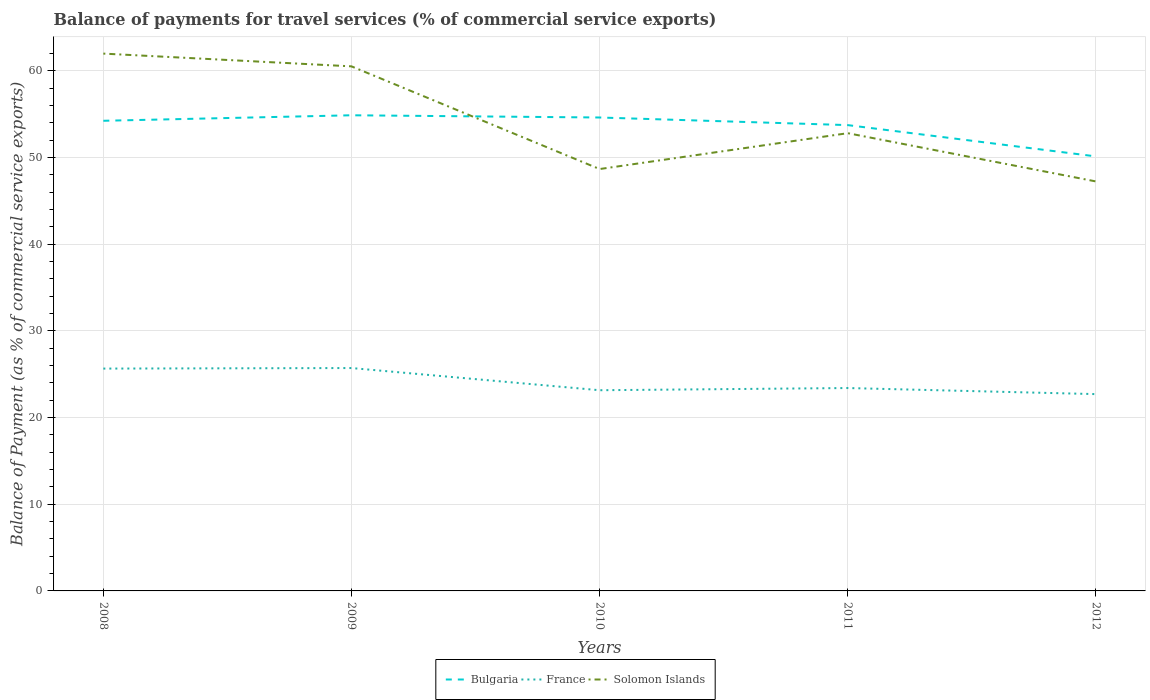How many different coloured lines are there?
Your answer should be very brief. 3. Does the line corresponding to France intersect with the line corresponding to Bulgaria?
Offer a very short reply. No. Across all years, what is the maximum balance of payments for travel services in France?
Offer a very short reply. 22.7. In which year was the balance of payments for travel services in France maximum?
Offer a terse response. 2012. What is the total balance of payments for travel services in Solomon Islands in the graph?
Offer a terse response. 13.28. What is the difference between the highest and the second highest balance of payments for travel services in Bulgaria?
Your answer should be compact. 4.74. What is the difference between the highest and the lowest balance of payments for travel services in Solomon Islands?
Offer a terse response. 2. How many lines are there?
Provide a short and direct response. 3. What is the difference between two consecutive major ticks on the Y-axis?
Offer a very short reply. 10. Are the values on the major ticks of Y-axis written in scientific E-notation?
Make the answer very short. No. Does the graph contain any zero values?
Ensure brevity in your answer.  No. How many legend labels are there?
Ensure brevity in your answer.  3. How are the legend labels stacked?
Give a very brief answer. Horizontal. What is the title of the graph?
Offer a very short reply. Balance of payments for travel services (% of commercial service exports). Does "Portugal" appear as one of the legend labels in the graph?
Make the answer very short. No. What is the label or title of the Y-axis?
Provide a succinct answer. Balance of Payment (as % of commercial service exports). What is the Balance of Payment (as % of commercial service exports) of Bulgaria in 2008?
Ensure brevity in your answer.  54.24. What is the Balance of Payment (as % of commercial service exports) in France in 2008?
Provide a short and direct response. 25.65. What is the Balance of Payment (as % of commercial service exports) in Solomon Islands in 2008?
Ensure brevity in your answer.  61.99. What is the Balance of Payment (as % of commercial service exports) in Bulgaria in 2009?
Give a very brief answer. 54.87. What is the Balance of Payment (as % of commercial service exports) in France in 2009?
Provide a short and direct response. 25.71. What is the Balance of Payment (as % of commercial service exports) in Solomon Islands in 2009?
Your response must be concise. 60.51. What is the Balance of Payment (as % of commercial service exports) in Bulgaria in 2010?
Offer a terse response. 54.61. What is the Balance of Payment (as % of commercial service exports) in France in 2010?
Provide a short and direct response. 23.15. What is the Balance of Payment (as % of commercial service exports) of Solomon Islands in 2010?
Your answer should be compact. 48.67. What is the Balance of Payment (as % of commercial service exports) of Bulgaria in 2011?
Provide a succinct answer. 53.74. What is the Balance of Payment (as % of commercial service exports) of France in 2011?
Provide a short and direct response. 23.4. What is the Balance of Payment (as % of commercial service exports) of Solomon Islands in 2011?
Keep it short and to the point. 52.8. What is the Balance of Payment (as % of commercial service exports) in Bulgaria in 2012?
Ensure brevity in your answer.  50.13. What is the Balance of Payment (as % of commercial service exports) of France in 2012?
Your response must be concise. 22.7. What is the Balance of Payment (as % of commercial service exports) of Solomon Islands in 2012?
Your answer should be very brief. 47.24. Across all years, what is the maximum Balance of Payment (as % of commercial service exports) of Bulgaria?
Your response must be concise. 54.87. Across all years, what is the maximum Balance of Payment (as % of commercial service exports) in France?
Offer a very short reply. 25.71. Across all years, what is the maximum Balance of Payment (as % of commercial service exports) of Solomon Islands?
Provide a succinct answer. 61.99. Across all years, what is the minimum Balance of Payment (as % of commercial service exports) in Bulgaria?
Provide a short and direct response. 50.13. Across all years, what is the minimum Balance of Payment (as % of commercial service exports) in France?
Your answer should be compact. 22.7. Across all years, what is the minimum Balance of Payment (as % of commercial service exports) of Solomon Islands?
Give a very brief answer. 47.24. What is the total Balance of Payment (as % of commercial service exports) in Bulgaria in the graph?
Offer a terse response. 267.59. What is the total Balance of Payment (as % of commercial service exports) of France in the graph?
Your response must be concise. 120.62. What is the total Balance of Payment (as % of commercial service exports) of Solomon Islands in the graph?
Keep it short and to the point. 271.21. What is the difference between the Balance of Payment (as % of commercial service exports) in Bulgaria in 2008 and that in 2009?
Offer a terse response. -0.64. What is the difference between the Balance of Payment (as % of commercial service exports) of France in 2008 and that in 2009?
Give a very brief answer. -0.06. What is the difference between the Balance of Payment (as % of commercial service exports) in Solomon Islands in 2008 and that in 2009?
Keep it short and to the point. 1.47. What is the difference between the Balance of Payment (as % of commercial service exports) of Bulgaria in 2008 and that in 2010?
Make the answer very short. -0.38. What is the difference between the Balance of Payment (as % of commercial service exports) in France in 2008 and that in 2010?
Offer a terse response. 2.5. What is the difference between the Balance of Payment (as % of commercial service exports) in Solomon Islands in 2008 and that in 2010?
Provide a short and direct response. 13.32. What is the difference between the Balance of Payment (as % of commercial service exports) in Bulgaria in 2008 and that in 2011?
Offer a very short reply. 0.5. What is the difference between the Balance of Payment (as % of commercial service exports) of France in 2008 and that in 2011?
Your response must be concise. 2.24. What is the difference between the Balance of Payment (as % of commercial service exports) of Solomon Islands in 2008 and that in 2011?
Provide a succinct answer. 9.18. What is the difference between the Balance of Payment (as % of commercial service exports) in Bulgaria in 2008 and that in 2012?
Your answer should be very brief. 4.11. What is the difference between the Balance of Payment (as % of commercial service exports) of France in 2008 and that in 2012?
Offer a terse response. 2.95. What is the difference between the Balance of Payment (as % of commercial service exports) of Solomon Islands in 2008 and that in 2012?
Make the answer very short. 14.75. What is the difference between the Balance of Payment (as % of commercial service exports) in Bulgaria in 2009 and that in 2010?
Your answer should be very brief. 0.26. What is the difference between the Balance of Payment (as % of commercial service exports) in France in 2009 and that in 2010?
Your answer should be very brief. 2.56. What is the difference between the Balance of Payment (as % of commercial service exports) in Solomon Islands in 2009 and that in 2010?
Your answer should be compact. 11.85. What is the difference between the Balance of Payment (as % of commercial service exports) in Bulgaria in 2009 and that in 2011?
Your response must be concise. 1.13. What is the difference between the Balance of Payment (as % of commercial service exports) in France in 2009 and that in 2011?
Make the answer very short. 2.31. What is the difference between the Balance of Payment (as % of commercial service exports) in Solomon Islands in 2009 and that in 2011?
Offer a very short reply. 7.71. What is the difference between the Balance of Payment (as % of commercial service exports) of Bulgaria in 2009 and that in 2012?
Provide a short and direct response. 4.74. What is the difference between the Balance of Payment (as % of commercial service exports) in France in 2009 and that in 2012?
Make the answer very short. 3.01. What is the difference between the Balance of Payment (as % of commercial service exports) of Solomon Islands in 2009 and that in 2012?
Provide a short and direct response. 13.28. What is the difference between the Balance of Payment (as % of commercial service exports) of Bulgaria in 2010 and that in 2011?
Provide a short and direct response. 0.88. What is the difference between the Balance of Payment (as % of commercial service exports) in France in 2010 and that in 2011?
Ensure brevity in your answer.  -0.25. What is the difference between the Balance of Payment (as % of commercial service exports) in Solomon Islands in 2010 and that in 2011?
Your answer should be compact. -4.14. What is the difference between the Balance of Payment (as % of commercial service exports) in Bulgaria in 2010 and that in 2012?
Offer a very short reply. 4.49. What is the difference between the Balance of Payment (as % of commercial service exports) in France in 2010 and that in 2012?
Your answer should be compact. 0.45. What is the difference between the Balance of Payment (as % of commercial service exports) of Solomon Islands in 2010 and that in 2012?
Offer a very short reply. 1.43. What is the difference between the Balance of Payment (as % of commercial service exports) of Bulgaria in 2011 and that in 2012?
Make the answer very short. 3.61. What is the difference between the Balance of Payment (as % of commercial service exports) in France in 2011 and that in 2012?
Your response must be concise. 0.7. What is the difference between the Balance of Payment (as % of commercial service exports) in Solomon Islands in 2011 and that in 2012?
Provide a succinct answer. 5.57. What is the difference between the Balance of Payment (as % of commercial service exports) in Bulgaria in 2008 and the Balance of Payment (as % of commercial service exports) in France in 2009?
Provide a short and direct response. 28.52. What is the difference between the Balance of Payment (as % of commercial service exports) of Bulgaria in 2008 and the Balance of Payment (as % of commercial service exports) of Solomon Islands in 2009?
Your response must be concise. -6.28. What is the difference between the Balance of Payment (as % of commercial service exports) in France in 2008 and the Balance of Payment (as % of commercial service exports) in Solomon Islands in 2009?
Provide a short and direct response. -34.87. What is the difference between the Balance of Payment (as % of commercial service exports) of Bulgaria in 2008 and the Balance of Payment (as % of commercial service exports) of France in 2010?
Your answer should be compact. 31.08. What is the difference between the Balance of Payment (as % of commercial service exports) in Bulgaria in 2008 and the Balance of Payment (as % of commercial service exports) in Solomon Islands in 2010?
Your answer should be very brief. 5.57. What is the difference between the Balance of Payment (as % of commercial service exports) in France in 2008 and the Balance of Payment (as % of commercial service exports) in Solomon Islands in 2010?
Your answer should be very brief. -23.02. What is the difference between the Balance of Payment (as % of commercial service exports) in Bulgaria in 2008 and the Balance of Payment (as % of commercial service exports) in France in 2011?
Offer a terse response. 30.83. What is the difference between the Balance of Payment (as % of commercial service exports) in Bulgaria in 2008 and the Balance of Payment (as % of commercial service exports) in Solomon Islands in 2011?
Provide a succinct answer. 1.43. What is the difference between the Balance of Payment (as % of commercial service exports) in France in 2008 and the Balance of Payment (as % of commercial service exports) in Solomon Islands in 2011?
Your answer should be compact. -27.16. What is the difference between the Balance of Payment (as % of commercial service exports) of Bulgaria in 2008 and the Balance of Payment (as % of commercial service exports) of France in 2012?
Your answer should be very brief. 31.53. What is the difference between the Balance of Payment (as % of commercial service exports) of Bulgaria in 2008 and the Balance of Payment (as % of commercial service exports) of Solomon Islands in 2012?
Give a very brief answer. 7. What is the difference between the Balance of Payment (as % of commercial service exports) in France in 2008 and the Balance of Payment (as % of commercial service exports) in Solomon Islands in 2012?
Your response must be concise. -21.59. What is the difference between the Balance of Payment (as % of commercial service exports) in Bulgaria in 2009 and the Balance of Payment (as % of commercial service exports) in France in 2010?
Your answer should be very brief. 31.72. What is the difference between the Balance of Payment (as % of commercial service exports) of Bulgaria in 2009 and the Balance of Payment (as % of commercial service exports) of Solomon Islands in 2010?
Offer a very short reply. 6.2. What is the difference between the Balance of Payment (as % of commercial service exports) of France in 2009 and the Balance of Payment (as % of commercial service exports) of Solomon Islands in 2010?
Offer a very short reply. -22.96. What is the difference between the Balance of Payment (as % of commercial service exports) of Bulgaria in 2009 and the Balance of Payment (as % of commercial service exports) of France in 2011?
Offer a terse response. 31.47. What is the difference between the Balance of Payment (as % of commercial service exports) of Bulgaria in 2009 and the Balance of Payment (as % of commercial service exports) of Solomon Islands in 2011?
Provide a short and direct response. 2.07. What is the difference between the Balance of Payment (as % of commercial service exports) in France in 2009 and the Balance of Payment (as % of commercial service exports) in Solomon Islands in 2011?
Keep it short and to the point. -27.09. What is the difference between the Balance of Payment (as % of commercial service exports) in Bulgaria in 2009 and the Balance of Payment (as % of commercial service exports) in France in 2012?
Provide a short and direct response. 32.17. What is the difference between the Balance of Payment (as % of commercial service exports) of Bulgaria in 2009 and the Balance of Payment (as % of commercial service exports) of Solomon Islands in 2012?
Your answer should be very brief. 7.63. What is the difference between the Balance of Payment (as % of commercial service exports) in France in 2009 and the Balance of Payment (as % of commercial service exports) in Solomon Islands in 2012?
Your answer should be very brief. -21.53. What is the difference between the Balance of Payment (as % of commercial service exports) in Bulgaria in 2010 and the Balance of Payment (as % of commercial service exports) in France in 2011?
Provide a succinct answer. 31.21. What is the difference between the Balance of Payment (as % of commercial service exports) of Bulgaria in 2010 and the Balance of Payment (as % of commercial service exports) of Solomon Islands in 2011?
Provide a short and direct response. 1.81. What is the difference between the Balance of Payment (as % of commercial service exports) in France in 2010 and the Balance of Payment (as % of commercial service exports) in Solomon Islands in 2011?
Offer a terse response. -29.65. What is the difference between the Balance of Payment (as % of commercial service exports) in Bulgaria in 2010 and the Balance of Payment (as % of commercial service exports) in France in 2012?
Your answer should be compact. 31.91. What is the difference between the Balance of Payment (as % of commercial service exports) of Bulgaria in 2010 and the Balance of Payment (as % of commercial service exports) of Solomon Islands in 2012?
Your response must be concise. 7.38. What is the difference between the Balance of Payment (as % of commercial service exports) of France in 2010 and the Balance of Payment (as % of commercial service exports) of Solomon Islands in 2012?
Keep it short and to the point. -24.09. What is the difference between the Balance of Payment (as % of commercial service exports) in Bulgaria in 2011 and the Balance of Payment (as % of commercial service exports) in France in 2012?
Your response must be concise. 31.03. What is the difference between the Balance of Payment (as % of commercial service exports) of Bulgaria in 2011 and the Balance of Payment (as % of commercial service exports) of Solomon Islands in 2012?
Your response must be concise. 6.5. What is the difference between the Balance of Payment (as % of commercial service exports) in France in 2011 and the Balance of Payment (as % of commercial service exports) in Solomon Islands in 2012?
Give a very brief answer. -23.83. What is the average Balance of Payment (as % of commercial service exports) in Bulgaria per year?
Your answer should be compact. 53.52. What is the average Balance of Payment (as % of commercial service exports) in France per year?
Ensure brevity in your answer.  24.12. What is the average Balance of Payment (as % of commercial service exports) of Solomon Islands per year?
Your answer should be compact. 54.24. In the year 2008, what is the difference between the Balance of Payment (as % of commercial service exports) in Bulgaria and Balance of Payment (as % of commercial service exports) in France?
Your response must be concise. 28.59. In the year 2008, what is the difference between the Balance of Payment (as % of commercial service exports) in Bulgaria and Balance of Payment (as % of commercial service exports) in Solomon Islands?
Ensure brevity in your answer.  -7.75. In the year 2008, what is the difference between the Balance of Payment (as % of commercial service exports) of France and Balance of Payment (as % of commercial service exports) of Solomon Islands?
Provide a short and direct response. -36.34. In the year 2009, what is the difference between the Balance of Payment (as % of commercial service exports) in Bulgaria and Balance of Payment (as % of commercial service exports) in France?
Offer a very short reply. 29.16. In the year 2009, what is the difference between the Balance of Payment (as % of commercial service exports) of Bulgaria and Balance of Payment (as % of commercial service exports) of Solomon Islands?
Make the answer very short. -5.64. In the year 2009, what is the difference between the Balance of Payment (as % of commercial service exports) of France and Balance of Payment (as % of commercial service exports) of Solomon Islands?
Your answer should be compact. -34.8. In the year 2010, what is the difference between the Balance of Payment (as % of commercial service exports) of Bulgaria and Balance of Payment (as % of commercial service exports) of France?
Your answer should be very brief. 31.46. In the year 2010, what is the difference between the Balance of Payment (as % of commercial service exports) in Bulgaria and Balance of Payment (as % of commercial service exports) in Solomon Islands?
Provide a short and direct response. 5.95. In the year 2010, what is the difference between the Balance of Payment (as % of commercial service exports) of France and Balance of Payment (as % of commercial service exports) of Solomon Islands?
Provide a succinct answer. -25.52. In the year 2011, what is the difference between the Balance of Payment (as % of commercial service exports) of Bulgaria and Balance of Payment (as % of commercial service exports) of France?
Offer a very short reply. 30.33. In the year 2011, what is the difference between the Balance of Payment (as % of commercial service exports) of Bulgaria and Balance of Payment (as % of commercial service exports) of Solomon Islands?
Ensure brevity in your answer.  0.93. In the year 2011, what is the difference between the Balance of Payment (as % of commercial service exports) in France and Balance of Payment (as % of commercial service exports) in Solomon Islands?
Provide a short and direct response. -29.4. In the year 2012, what is the difference between the Balance of Payment (as % of commercial service exports) of Bulgaria and Balance of Payment (as % of commercial service exports) of France?
Provide a succinct answer. 27.42. In the year 2012, what is the difference between the Balance of Payment (as % of commercial service exports) of Bulgaria and Balance of Payment (as % of commercial service exports) of Solomon Islands?
Provide a short and direct response. 2.89. In the year 2012, what is the difference between the Balance of Payment (as % of commercial service exports) of France and Balance of Payment (as % of commercial service exports) of Solomon Islands?
Provide a short and direct response. -24.54. What is the ratio of the Balance of Payment (as % of commercial service exports) of Bulgaria in 2008 to that in 2009?
Ensure brevity in your answer.  0.99. What is the ratio of the Balance of Payment (as % of commercial service exports) of Solomon Islands in 2008 to that in 2009?
Give a very brief answer. 1.02. What is the ratio of the Balance of Payment (as % of commercial service exports) in Bulgaria in 2008 to that in 2010?
Keep it short and to the point. 0.99. What is the ratio of the Balance of Payment (as % of commercial service exports) of France in 2008 to that in 2010?
Offer a very short reply. 1.11. What is the ratio of the Balance of Payment (as % of commercial service exports) of Solomon Islands in 2008 to that in 2010?
Offer a terse response. 1.27. What is the ratio of the Balance of Payment (as % of commercial service exports) of Bulgaria in 2008 to that in 2011?
Offer a very short reply. 1.01. What is the ratio of the Balance of Payment (as % of commercial service exports) in France in 2008 to that in 2011?
Give a very brief answer. 1.1. What is the ratio of the Balance of Payment (as % of commercial service exports) of Solomon Islands in 2008 to that in 2011?
Your answer should be compact. 1.17. What is the ratio of the Balance of Payment (as % of commercial service exports) in Bulgaria in 2008 to that in 2012?
Ensure brevity in your answer.  1.08. What is the ratio of the Balance of Payment (as % of commercial service exports) in France in 2008 to that in 2012?
Make the answer very short. 1.13. What is the ratio of the Balance of Payment (as % of commercial service exports) in Solomon Islands in 2008 to that in 2012?
Your answer should be compact. 1.31. What is the ratio of the Balance of Payment (as % of commercial service exports) in France in 2009 to that in 2010?
Make the answer very short. 1.11. What is the ratio of the Balance of Payment (as % of commercial service exports) in Solomon Islands in 2009 to that in 2010?
Your response must be concise. 1.24. What is the ratio of the Balance of Payment (as % of commercial service exports) in Bulgaria in 2009 to that in 2011?
Your answer should be compact. 1.02. What is the ratio of the Balance of Payment (as % of commercial service exports) in France in 2009 to that in 2011?
Give a very brief answer. 1.1. What is the ratio of the Balance of Payment (as % of commercial service exports) in Solomon Islands in 2009 to that in 2011?
Keep it short and to the point. 1.15. What is the ratio of the Balance of Payment (as % of commercial service exports) in Bulgaria in 2009 to that in 2012?
Your response must be concise. 1.09. What is the ratio of the Balance of Payment (as % of commercial service exports) in France in 2009 to that in 2012?
Your answer should be very brief. 1.13. What is the ratio of the Balance of Payment (as % of commercial service exports) of Solomon Islands in 2009 to that in 2012?
Offer a terse response. 1.28. What is the ratio of the Balance of Payment (as % of commercial service exports) in Bulgaria in 2010 to that in 2011?
Give a very brief answer. 1.02. What is the ratio of the Balance of Payment (as % of commercial service exports) of Solomon Islands in 2010 to that in 2011?
Ensure brevity in your answer.  0.92. What is the ratio of the Balance of Payment (as % of commercial service exports) in Bulgaria in 2010 to that in 2012?
Your response must be concise. 1.09. What is the ratio of the Balance of Payment (as % of commercial service exports) in France in 2010 to that in 2012?
Ensure brevity in your answer.  1.02. What is the ratio of the Balance of Payment (as % of commercial service exports) in Solomon Islands in 2010 to that in 2012?
Your answer should be very brief. 1.03. What is the ratio of the Balance of Payment (as % of commercial service exports) in Bulgaria in 2011 to that in 2012?
Ensure brevity in your answer.  1.07. What is the ratio of the Balance of Payment (as % of commercial service exports) of France in 2011 to that in 2012?
Provide a short and direct response. 1.03. What is the ratio of the Balance of Payment (as % of commercial service exports) of Solomon Islands in 2011 to that in 2012?
Your answer should be compact. 1.12. What is the difference between the highest and the second highest Balance of Payment (as % of commercial service exports) in Bulgaria?
Provide a succinct answer. 0.26. What is the difference between the highest and the second highest Balance of Payment (as % of commercial service exports) in France?
Provide a succinct answer. 0.06. What is the difference between the highest and the second highest Balance of Payment (as % of commercial service exports) of Solomon Islands?
Ensure brevity in your answer.  1.47. What is the difference between the highest and the lowest Balance of Payment (as % of commercial service exports) in Bulgaria?
Offer a very short reply. 4.74. What is the difference between the highest and the lowest Balance of Payment (as % of commercial service exports) of France?
Your response must be concise. 3.01. What is the difference between the highest and the lowest Balance of Payment (as % of commercial service exports) in Solomon Islands?
Offer a terse response. 14.75. 